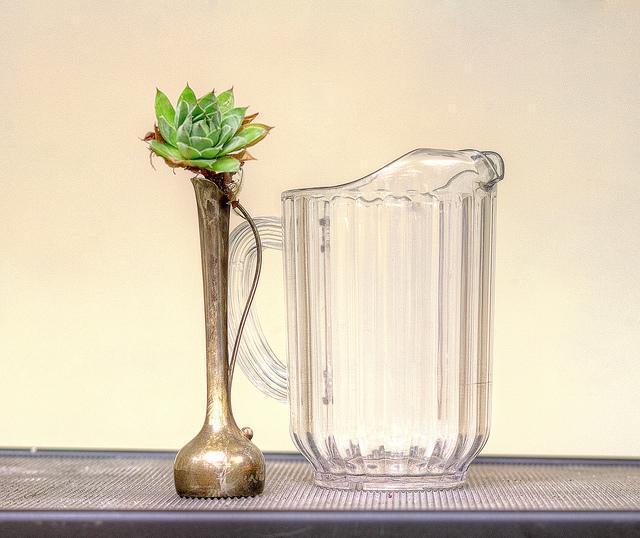How many bottles are on the table?
Give a very brief answer. 0. 